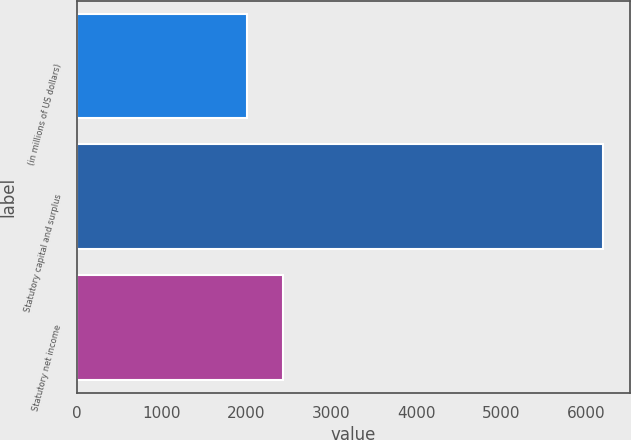Convert chart. <chart><loc_0><loc_0><loc_500><loc_500><bar_chart><fcel>(in millions of US dollars)<fcel>Statutory capital and surplus<fcel>Statutory net income<nl><fcel>2008<fcel>6205<fcel>2427.7<nl></chart> 